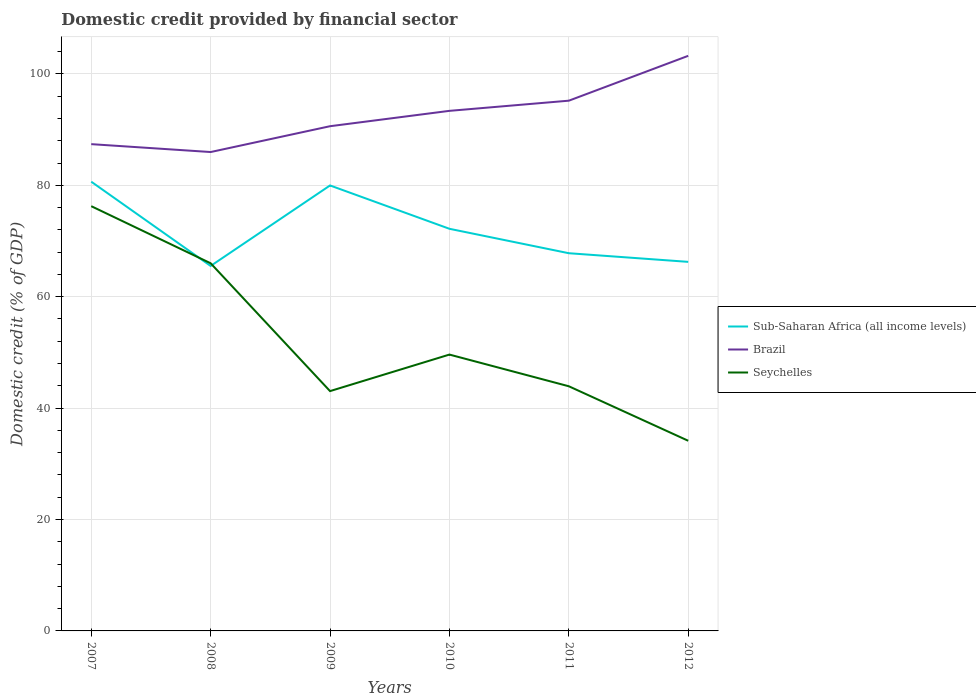How many different coloured lines are there?
Keep it short and to the point. 3. Does the line corresponding to Brazil intersect with the line corresponding to Sub-Saharan Africa (all income levels)?
Give a very brief answer. No. Is the number of lines equal to the number of legend labels?
Keep it short and to the point. Yes. Across all years, what is the maximum domestic credit in Sub-Saharan Africa (all income levels)?
Keep it short and to the point. 65.52. In which year was the domestic credit in Brazil maximum?
Your answer should be compact. 2008. What is the total domestic credit in Seychelles in the graph?
Keep it short and to the point. 5.69. What is the difference between the highest and the second highest domestic credit in Seychelles?
Make the answer very short. 42.11. Is the domestic credit in Brazil strictly greater than the domestic credit in Seychelles over the years?
Ensure brevity in your answer.  No. How many lines are there?
Ensure brevity in your answer.  3. How many years are there in the graph?
Your answer should be very brief. 6. Does the graph contain grids?
Your answer should be compact. Yes. Where does the legend appear in the graph?
Offer a terse response. Center right. How many legend labels are there?
Make the answer very short. 3. How are the legend labels stacked?
Provide a succinct answer. Vertical. What is the title of the graph?
Make the answer very short. Domestic credit provided by financial sector. What is the label or title of the Y-axis?
Provide a succinct answer. Domestic credit (% of GDP). What is the Domestic credit (% of GDP) of Sub-Saharan Africa (all income levels) in 2007?
Provide a short and direct response. 80.65. What is the Domestic credit (% of GDP) in Brazil in 2007?
Your response must be concise. 87.39. What is the Domestic credit (% of GDP) of Seychelles in 2007?
Keep it short and to the point. 76.25. What is the Domestic credit (% of GDP) of Sub-Saharan Africa (all income levels) in 2008?
Offer a very short reply. 65.52. What is the Domestic credit (% of GDP) of Brazil in 2008?
Provide a succinct answer. 85.97. What is the Domestic credit (% of GDP) of Seychelles in 2008?
Offer a very short reply. 66. What is the Domestic credit (% of GDP) of Sub-Saharan Africa (all income levels) in 2009?
Your answer should be very brief. 79.97. What is the Domestic credit (% of GDP) in Brazil in 2009?
Give a very brief answer. 90.61. What is the Domestic credit (% of GDP) of Seychelles in 2009?
Your answer should be compact. 43.05. What is the Domestic credit (% of GDP) of Sub-Saharan Africa (all income levels) in 2010?
Offer a very short reply. 72.19. What is the Domestic credit (% of GDP) of Brazil in 2010?
Provide a succinct answer. 93.36. What is the Domestic credit (% of GDP) in Seychelles in 2010?
Give a very brief answer. 49.61. What is the Domestic credit (% of GDP) in Sub-Saharan Africa (all income levels) in 2011?
Give a very brief answer. 67.81. What is the Domestic credit (% of GDP) in Brazil in 2011?
Make the answer very short. 95.19. What is the Domestic credit (% of GDP) in Seychelles in 2011?
Keep it short and to the point. 43.92. What is the Domestic credit (% of GDP) in Sub-Saharan Africa (all income levels) in 2012?
Provide a short and direct response. 66.26. What is the Domestic credit (% of GDP) of Brazil in 2012?
Make the answer very short. 103.24. What is the Domestic credit (% of GDP) in Seychelles in 2012?
Your answer should be very brief. 34.14. Across all years, what is the maximum Domestic credit (% of GDP) in Sub-Saharan Africa (all income levels)?
Offer a terse response. 80.65. Across all years, what is the maximum Domestic credit (% of GDP) in Brazil?
Your answer should be compact. 103.24. Across all years, what is the maximum Domestic credit (% of GDP) in Seychelles?
Your answer should be very brief. 76.25. Across all years, what is the minimum Domestic credit (% of GDP) in Sub-Saharan Africa (all income levels)?
Keep it short and to the point. 65.52. Across all years, what is the minimum Domestic credit (% of GDP) in Brazil?
Keep it short and to the point. 85.97. Across all years, what is the minimum Domestic credit (% of GDP) of Seychelles?
Make the answer very short. 34.14. What is the total Domestic credit (% of GDP) in Sub-Saharan Africa (all income levels) in the graph?
Ensure brevity in your answer.  432.39. What is the total Domestic credit (% of GDP) in Brazil in the graph?
Make the answer very short. 555.77. What is the total Domestic credit (% of GDP) in Seychelles in the graph?
Give a very brief answer. 312.98. What is the difference between the Domestic credit (% of GDP) of Sub-Saharan Africa (all income levels) in 2007 and that in 2008?
Your answer should be compact. 15.13. What is the difference between the Domestic credit (% of GDP) of Brazil in 2007 and that in 2008?
Your answer should be compact. 1.42. What is the difference between the Domestic credit (% of GDP) in Seychelles in 2007 and that in 2008?
Your response must be concise. 10.25. What is the difference between the Domestic credit (% of GDP) in Sub-Saharan Africa (all income levels) in 2007 and that in 2009?
Your answer should be very brief. 0.68. What is the difference between the Domestic credit (% of GDP) of Brazil in 2007 and that in 2009?
Your answer should be very brief. -3.22. What is the difference between the Domestic credit (% of GDP) of Seychelles in 2007 and that in 2009?
Your answer should be very brief. 33.2. What is the difference between the Domestic credit (% of GDP) in Sub-Saharan Africa (all income levels) in 2007 and that in 2010?
Offer a very short reply. 8.45. What is the difference between the Domestic credit (% of GDP) in Brazil in 2007 and that in 2010?
Your answer should be compact. -5.98. What is the difference between the Domestic credit (% of GDP) of Seychelles in 2007 and that in 2010?
Provide a succinct answer. 26.64. What is the difference between the Domestic credit (% of GDP) of Sub-Saharan Africa (all income levels) in 2007 and that in 2011?
Provide a succinct answer. 12.84. What is the difference between the Domestic credit (% of GDP) in Brazil in 2007 and that in 2011?
Ensure brevity in your answer.  -7.8. What is the difference between the Domestic credit (% of GDP) in Seychelles in 2007 and that in 2011?
Offer a very short reply. 32.33. What is the difference between the Domestic credit (% of GDP) in Sub-Saharan Africa (all income levels) in 2007 and that in 2012?
Your response must be concise. 14.39. What is the difference between the Domestic credit (% of GDP) of Brazil in 2007 and that in 2012?
Provide a succinct answer. -15.86. What is the difference between the Domestic credit (% of GDP) in Seychelles in 2007 and that in 2012?
Provide a succinct answer. 42.11. What is the difference between the Domestic credit (% of GDP) in Sub-Saharan Africa (all income levels) in 2008 and that in 2009?
Your answer should be compact. -14.45. What is the difference between the Domestic credit (% of GDP) of Brazil in 2008 and that in 2009?
Make the answer very short. -4.64. What is the difference between the Domestic credit (% of GDP) in Seychelles in 2008 and that in 2009?
Offer a very short reply. 22.95. What is the difference between the Domestic credit (% of GDP) in Sub-Saharan Africa (all income levels) in 2008 and that in 2010?
Your answer should be compact. -6.67. What is the difference between the Domestic credit (% of GDP) in Brazil in 2008 and that in 2010?
Ensure brevity in your answer.  -7.39. What is the difference between the Domestic credit (% of GDP) in Seychelles in 2008 and that in 2010?
Your answer should be compact. 16.39. What is the difference between the Domestic credit (% of GDP) in Sub-Saharan Africa (all income levels) in 2008 and that in 2011?
Keep it short and to the point. -2.29. What is the difference between the Domestic credit (% of GDP) in Brazil in 2008 and that in 2011?
Your response must be concise. -9.22. What is the difference between the Domestic credit (% of GDP) of Seychelles in 2008 and that in 2011?
Give a very brief answer. 22.08. What is the difference between the Domestic credit (% of GDP) in Sub-Saharan Africa (all income levels) in 2008 and that in 2012?
Your answer should be very brief. -0.73. What is the difference between the Domestic credit (% of GDP) in Brazil in 2008 and that in 2012?
Offer a terse response. -17.27. What is the difference between the Domestic credit (% of GDP) of Seychelles in 2008 and that in 2012?
Offer a terse response. 31.86. What is the difference between the Domestic credit (% of GDP) in Sub-Saharan Africa (all income levels) in 2009 and that in 2010?
Your response must be concise. 7.78. What is the difference between the Domestic credit (% of GDP) of Brazil in 2009 and that in 2010?
Ensure brevity in your answer.  -2.76. What is the difference between the Domestic credit (% of GDP) of Seychelles in 2009 and that in 2010?
Provide a short and direct response. -6.56. What is the difference between the Domestic credit (% of GDP) of Sub-Saharan Africa (all income levels) in 2009 and that in 2011?
Give a very brief answer. 12.16. What is the difference between the Domestic credit (% of GDP) of Brazil in 2009 and that in 2011?
Make the answer very short. -4.58. What is the difference between the Domestic credit (% of GDP) of Seychelles in 2009 and that in 2011?
Provide a short and direct response. -0.87. What is the difference between the Domestic credit (% of GDP) of Sub-Saharan Africa (all income levels) in 2009 and that in 2012?
Your answer should be very brief. 13.72. What is the difference between the Domestic credit (% of GDP) in Brazil in 2009 and that in 2012?
Your response must be concise. -12.64. What is the difference between the Domestic credit (% of GDP) in Seychelles in 2009 and that in 2012?
Ensure brevity in your answer.  8.92. What is the difference between the Domestic credit (% of GDP) of Sub-Saharan Africa (all income levels) in 2010 and that in 2011?
Ensure brevity in your answer.  4.39. What is the difference between the Domestic credit (% of GDP) of Brazil in 2010 and that in 2011?
Keep it short and to the point. -1.83. What is the difference between the Domestic credit (% of GDP) in Seychelles in 2010 and that in 2011?
Keep it short and to the point. 5.69. What is the difference between the Domestic credit (% of GDP) in Sub-Saharan Africa (all income levels) in 2010 and that in 2012?
Make the answer very short. 5.94. What is the difference between the Domestic credit (% of GDP) in Brazil in 2010 and that in 2012?
Give a very brief answer. -9.88. What is the difference between the Domestic credit (% of GDP) in Seychelles in 2010 and that in 2012?
Make the answer very short. 15.47. What is the difference between the Domestic credit (% of GDP) of Sub-Saharan Africa (all income levels) in 2011 and that in 2012?
Your answer should be compact. 1.55. What is the difference between the Domestic credit (% of GDP) in Brazil in 2011 and that in 2012?
Offer a terse response. -8.05. What is the difference between the Domestic credit (% of GDP) in Seychelles in 2011 and that in 2012?
Ensure brevity in your answer.  9.78. What is the difference between the Domestic credit (% of GDP) in Sub-Saharan Africa (all income levels) in 2007 and the Domestic credit (% of GDP) in Brazil in 2008?
Keep it short and to the point. -5.32. What is the difference between the Domestic credit (% of GDP) of Sub-Saharan Africa (all income levels) in 2007 and the Domestic credit (% of GDP) of Seychelles in 2008?
Your answer should be compact. 14.65. What is the difference between the Domestic credit (% of GDP) in Brazil in 2007 and the Domestic credit (% of GDP) in Seychelles in 2008?
Keep it short and to the point. 21.38. What is the difference between the Domestic credit (% of GDP) in Sub-Saharan Africa (all income levels) in 2007 and the Domestic credit (% of GDP) in Brazil in 2009?
Ensure brevity in your answer.  -9.96. What is the difference between the Domestic credit (% of GDP) of Sub-Saharan Africa (all income levels) in 2007 and the Domestic credit (% of GDP) of Seychelles in 2009?
Offer a very short reply. 37.59. What is the difference between the Domestic credit (% of GDP) in Brazil in 2007 and the Domestic credit (% of GDP) in Seychelles in 2009?
Keep it short and to the point. 44.33. What is the difference between the Domestic credit (% of GDP) in Sub-Saharan Africa (all income levels) in 2007 and the Domestic credit (% of GDP) in Brazil in 2010?
Provide a short and direct response. -12.72. What is the difference between the Domestic credit (% of GDP) in Sub-Saharan Africa (all income levels) in 2007 and the Domestic credit (% of GDP) in Seychelles in 2010?
Your answer should be compact. 31.04. What is the difference between the Domestic credit (% of GDP) in Brazil in 2007 and the Domestic credit (% of GDP) in Seychelles in 2010?
Offer a very short reply. 37.78. What is the difference between the Domestic credit (% of GDP) in Sub-Saharan Africa (all income levels) in 2007 and the Domestic credit (% of GDP) in Brazil in 2011?
Offer a very short reply. -14.54. What is the difference between the Domestic credit (% of GDP) of Sub-Saharan Africa (all income levels) in 2007 and the Domestic credit (% of GDP) of Seychelles in 2011?
Keep it short and to the point. 36.73. What is the difference between the Domestic credit (% of GDP) in Brazil in 2007 and the Domestic credit (% of GDP) in Seychelles in 2011?
Keep it short and to the point. 43.47. What is the difference between the Domestic credit (% of GDP) in Sub-Saharan Africa (all income levels) in 2007 and the Domestic credit (% of GDP) in Brazil in 2012?
Provide a succinct answer. -22.6. What is the difference between the Domestic credit (% of GDP) of Sub-Saharan Africa (all income levels) in 2007 and the Domestic credit (% of GDP) of Seychelles in 2012?
Make the answer very short. 46.51. What is the difference between the Domestic credit (% of GDP) of Brazil in 2007 and the Domestic credit (% of GDP) of Seychelles in 2012?
Provide a succinct answer. 53.25. What is the difference between the Domestic credit (% of GDP) in Sub-Saharan Africa (all income levels) in 2008 and the Domestic credit (% of GDP) in Brazil in 2009?
Provide a succinct answer. -25.09. What is the difference between the Domestic credit (% of GDP) in Sub-Saharan Africa (all income levels) in 2008 and the Domestic credit (% of GDP) in Seychelles in 2009?
Make the answer very short. 22.47. What is the difference between the Domestic credit (% of GDP) of Brazil in 2008 and the Domestic credit (% of GDP) of Seychelles in 2009?
Keep it short and to the point. 42.92. What is the difference between the Domestic credit (% of GDP) in Sub-Saharan Africa (all income levels) in 2008 and the Domestic credit (% of GDP) in Brazil in 2010?
Provide a succinct answer. -27.84. What is the difference between the Domestic credit (% of GDP) of Sub-Saharan Africa (all income levels) in 2008 and the Domestic credit (% of GDP) of Seychelles in 2010?
Give a very brief answer. 15.91. What is the difference between the Domestic credit (% of GDP) of Brazil in 2008 and the Domestic credit (% of GDP) of Seychelles in 2010?
Ensure brevity in your answer.  36.36. What is the difference between the Domestic credit (% of GDP) in Sub-Saharan Africa (all income levels) in 2008 and the Domestic credit (% of GDP) in Brazil in 2011?
Your response must be concise. -29.67. What is the difference between the Domestic credit (% of GDP) in Sub-Saharan Africa (all income levels) in 2008 and the Domestic credit (% of GDP) in Seychelles in 2011?
Your response must be concise. 21.6. What is the difference between the Domestic credit (% of GDP) in Brazil in 2008 and the Domestic credit (% of GDP) in Seychelles in 2011?
Your answer should be compact. 42.05. What is the difference between the Domestic credit (% of GDP) of Sub-Saharan Africa (all income levels) in 2008 and the Domestic credit (% of GDP) of Brazil in 2012?
Keep it short and to the point. -37.72. What is the difference between the Domestic credit (% of GDP) in Sub-Saharan Africa (all income levels) in 2008 and the Domestic credit (% of GDP) in Seychelles in 2012?
Provide a succinct answer. 31.38. What is the difference between the Domestic credit (% of GDP) of Brazil in 2008 and the Domestic credit (% of GDP) of Seychelles in 2012?
Provide a short and direct response. 51.83. What is the difference between the Domestic credit (% of GDP) in Sub-Saharan Africa (all income levels) in 2009 and the Domestic credit (% of GDP) in Brazil in 2010?
Keep it short and to the point. -13.39. What is the difference between the Domestic credit (% of GDP) of Sub-Saharan Africa (all income levels) in 2009 and the Domestic credit (% of GDP) of Seychelles in 2010?
Offer a very short reply. 30.36. What is the difference between the Domestic credit (% of GDP) in Brazil in 2009 and the Domestic credit (% of GDP) in Seychelles in 2010?
Provide a succinct answer. 41. What is the difference between the Domestic credit (% of GDP) of Sub-Saharan Africa (all income levels) in 2009 and the Domestic credit (% of GDP) of Brazil in 2011?
Offer a very short reply. -15.22. What is the difference between the Domestic credit (% of GDP) in Sub-Saharan Africa (all income levels) in 2009 and the Domestic credit (% of GDP) in Seychelles in 2011?
Offer a very short reply. 36.05. What is the difference between the Domestic credit (% of GDP) of Brazil in 2009 and the Domestic credit (% of GDP) of Seychelles in 2011?
Your response must be concise. 46.69. What is the difference between the Domestic credit (% of GDP) in Sub-Saharan Africa (all income levels) in 2009 and the Domestic credit (% of GDP) in Brazil in 2012?
Ensure brevity in your answer.  -23.27. What is the difference between the Domestic credit (% of GDP) of Sub-Saharan Africa (all income levels) in 2009 and the Domestic credit (% of GDP) of Seychelles in 2012?
Your answer should be very brief. 45.83. What is the difference between the Domestic credit (% of GDP) in Brazil in 2009 and the Domestic credit (% of GDP) in Seychelles in 2012?
Your response must be concise. 56.47. What is the difference between the Domestic credit (% of GDP) of Sub-Saharan Africa (all income levels) in 2010 and the Domestic credit (% of GDP) of Brazil in 2011?
Your answer should be compact. -23. What is the difference between the Domestic credit (% of GDP) in Sub-Saharan Africa (all income levels) in 2010 and the Domestic credit (% of GDP) in Seychelles in 2011?
Ensure brevity in your answer.  28.27. What is the difference between the Domestic credit (% of GDP) of Brazil in 2010 and the Domestic credit (% of GDP) of Seychelles in 2011?
Your answer should be very brief. 49.44. What is the difference between the Domestic credit (% of GDP) of Sub-Saharan Africa (all income levels) in 2010 and the Domestic credit (% of GDP) of Brazil in 2012?
Make the answer very short. -31.05. What is the difference between the Domestic credit (% of GDP) of Sub-Saharan Africa (all income levels) in 2010 and the Domestic credit (% of GDP) of Seychelles in 2012?
Your answer should be compact. 38.05. What is the difference between the Domestic credit (% of GDP) of Brazil in 2010 and the Domestic credit (% of GDP) of Seychelles in 2012?
Provide a short and direct response. 59.23. What is the difference between the Domestic credit (% of GDP) in Sub-Saharan Africa (all income levels) in 2011 and the Domestic credit (% of GDP) in Brazil in 2012?
Your response must be concise. -35.44. What is the difference between the Domestic credit (% of GDP) in Sub-Saharan Africa (all income levels) in 2011 and the Domestic credit (% of GDP) in Seychelles in 2012?
Make the answer very short. 33.67. What is the difference between the Domestic credit (% of GDP) of Brazil in 2011 and the Domestic credit (% of GDP) of Seychelles in 2012?
Keep it short and to the point. 61.05. What is the average Domestic credit (% of GDP) in Sub-Saharan Africa (all income levels) per year?
Provide a succinct answer. 72.07. What is the average Domestic credit (% of GDP) of Brazil per year?
Provide a succinct answer. 92.63. What is the average Domestic credit (% of GDP) of Seychelles per year?
Provide a short and direct response. 52.16. In the year 2007, what is the difference between the Domestic credit (% of GDP) of Sub-Saharan Africa (all income levels) and Domestic credit (% of GDP) of Brazil?
Your response must be concise. -6.74. In the year 2007, what is the difference between the Domestic credit (% of GDP) in Sub-Saharan Africa (all income levels) and Domestic credit (% of GDP) in Seychelles?
Provide a succinct answer. 4.4. In the year 2007, what is the difference between the Domestic credit (% of GDP) of Brazil and Domestic credit (% of GDP) of Seychelles?
Give a very brief answer. 11.13. In the year 2008, what is the difference between the Domestic credit (% of GDP) of Sub-Saharan Africa (all income levels) and Domestic credit (% of GDP) of Brazil?
Your answer should be very brief. -20.45. In the year 2008, what is the difference between the Domestic credit (% of GDP) of Sub-Saharan Africa (all income levels) and Domestic credit (% of GDP) of Seychelles?
Your answer should be compact. -0.48. In the year 2008, what is the difference between the Domestic credit (% of GDP) in Brazil and Domestic credit (% of GDP) in Seychelles?
Offer a terse response. 19.97. In the year 2009, what is the difference between the Domestic credit (% of GDP) in Sub-Saharan Africa (all income levels) and Domestic credit (% of GDP) in Brazil?
Give a very brief answer. -10.64. In the year 2009, what is the difference between the Domestic credit (% of GDP) in Sub-Saharan Africa (all income levels) and Domestic credit (% of GDP) in Seychelles?
Provide a short and direct response. 36.92. In the year 2009, what is the difference between the Domestic credit (% of GDP) of Brazil and Domestic credit (% of GDP) of Seychelles?
Your response must be concise. 47.55. In the year 2010, what is the difference between the Domestic credit (% of GDP) of Sub-Saharan Africa (all income levels) and Domestic credit (% of GDP) of Brazil?
Offer a very short reply. -21.17. In the year 2010, what is the difference between the Domestic credit (% of GDP) of Sub-Saharan Africa (all income levels) and Domestic credit (% of GDP) of Seychelles?
Your response must be concise. 22.58. In the year 2010, what is the difference between the Domestic credit (% of GDP) of Brazil and Domestic credit (% of GDP) of Seychelles?
Your response must be concise. 43.75. In the year 2011, what is the difference between the Domestic credit (% of GDP) of Sub-Saharan Africa (all income levels) and Domestic credit (% of GDP) of Brazil?
Your answer should be compact. -27.38. In the year 2011, what is the difference between the Domestic credit (% of GDP) of Sub-Saharan Africa (all income levels) and Domestic credit (% of GDP) of Seychelles?
Your answer should be compact. 23.89. In the year 2011, what is the difference between the Domestic credit (% of GDP) in Brazil and Domestic credit (% of GDP) in Seychelles?
Keep it short and to the point. 51.27. In the year 2012, what is the difference between the Domestic credit (% of GDP) in Sub-Saharan Africa (all income levels) and Domestic credit (% of GDP) in Brazil?
Your answer should be very brief. -36.99. In the year 2012, what is the difference between the Domestic credit (% of GDP) of Sub-Saharan Africa (all income levels) and Domestic credit (% of GDP) of Seychelles?
Provide a succinct answer. 32.12. In the year 2012, what is the difference between the Domestic credit (% of GDP) of Brazil and Domestic credit (% of GDP) of Seychelles?
Offer a terse response. 69.11. What is the ratio of the Domestic credit (% of GDP) in Sub-Saharan Africa (all income levels) in 2007 to that in 2008?
Your response must be concise. 1.23. What is the ratio of the Domestic credit (% of GDP) of Brazil in 2007 to that in 2008?
Your answer should be very brief. 1.02. What is the ratio of the Domestic credit (% of GDP) in Seychelles in 2007 to that in 2008?
Your answer should be very brief. 1.16. What is the ratio of the Domestic credit (% of GDP) of Sub-Saharan Africa (all income levels) in 2007 to that in 2009?
Ensure brevity in your answer.  1.01. What is the ratio of the Domestic credit (% of GDP) of Brazil in 2007 to that in 2009?
Provide a succinct answer. 0.96. What is the ratio of the Domestic credit (% of GDP) of Seychelles in 2007 to that in 2009?
Give a very brief answer. 1.77. What is the ratio of the Domestic credit (% of GDP) in Sub-Saharan Africa (all income levels) in 2007 to that in 2010?
Your response must be concise. 1.12. What is the ratio of the Domestic credit (% of GDP) of Brazil in 2007 to that in 2010?
Your response must be concise. 0.94. What is the ratio of the Domestic credit (% of GDP) in Seychelles in 2007 to that in 2010?
Offer a terse response. 1.54. What is the ratio of the Domestic credit (% of GDP) in Sub-Saharan Africa (all income levels) in 2007 to that in 2011?
Your answer should be very brief. 1.19. What is the ratio of the Domestic credit (% of GDP) of Brazil in 2007 to that in 2011?
Make the answer very short. 0.92. What is the ratio of the Domestic credit (% of GDP) in Seychelles in 2007 to that in 2011?
Provide a succinct answer. 1.74. What is the ratio of the Domestic credit (% of GDP) in Sub-Saharan Africa (all income levels) in 2007 to that in 2012?
Offer a terse response. 1.22. What is the ratio of the Domestic credit (% of GDP) in Brazil in 2007 to that in 2012?
Give a very brief answer. 0.85. What is the ratio of the Domestic credit (% of GDP) in Seychelles in 2007 to that in 2012?
Your answer should be compact. 2.23. What is the ratio of the Domestic credit (% of GDP) in Sub-Saharan Africa (all income levels) in 2008 to that in 2009?
Your response must be concise. 0.82. What is the ratio of the Domestic credit (% of GDP) in Brazil in 2008 to that in 2009?
Offer a terse response. 0.95. What is the ratio of the Domestic credit (% of GDP) of Seychelles in 2008 to that in 2009?
Your response must be concise. 1.53. What is the ratio of the Domestic credit (% of GDP) of Sub-Saharan Africa (all income levels) in 2008 to that in 2010?
Your response must be concise. 0.91. What is the ratio of the Domestic credit (% of GDP) of Brazil in 2008 to that in 2010?
Provide a short and direct response. 0.92. What is the ratio of the Domestic credit (% of GDP) of Seychelles in 2008 to that in 2010?
Keep it short and to the point. 1.33. What is the ratio of the Domestic credit (% of GDP) of Sub-Saharan Africa (all income levels) in 2008 to that in 2011?
Provide a succinct answer. 0.97. What is the ratio of the Domestic credit (% of GDP) of Brazil in 2008 to that in 2011?
Ensure brevity in your answer.  0.9. What is the ratio of the Domestic credit (% of GDP) of Seychelles in 2008 to that in 2011?
Give a very brief answer. 1.5. What is the ratio of the Domestic credit (% of GDP) of Sub-Saharan Africa (all income levels) in 2008 to that in 2012?
Offer a terse response. 0.99. What is the ratio of the Domestic credit (% of GDP) of Brazil in 2008 to that in 2012?
Your answer should be very brief. 0.83. What is the ratio of the Domestic credit (% of GDP) of Seychelles in 2008 to that in 2012?
Provide a short and direct response. 1.93. What is the ratio of the Domestic credit (% of GDP) of Sub-Saharan Africa (all income levels) in 2009 to that in 2010?
Your answer should be very brief. 1.11. What is the ratio of the Domestic credit (% of GDP) of Brazil in 2009 to that in 2010?
Offer a very short reply. 0.97. What is the ratio of the Domestic credit (% of GDP) of Seychelles in 2009 to that in 2010?
Provide a short and direct response. 0.87. What is the ratio of the Domestic credit (% of GDP) in Sub-Saharan Africa (all income levels) in 2009 to that in 2011?
Your answer should be compact. 1.18. What is the ratio of the Domestic credit (% of GDP) of Brazil in 2009 to that in 2011?
Keep it short and to the point. 0.95. What is the ratio of the Domestic credit (% of GDP) of Seychelles in 2009 to that in 2011?
Your answer should be very brief. 0.98. What is the ratio of the Domestic credit (% of GDP) of Sub-Saharan Africa (all income levels) in 2009 to that in 2012?
Your answer should be very brief. 1.21. What is the ratio of the Domestic credit (% of GDP) in Brazil in 2009 to that in 2012?
Provide a succinct answer. 0.88. What is the ratio of the Domestic credit (% of GDP) in Seychelles in 2009 to that in 2012?
Your answer should be very brief. 1.26. What is the ratio of the Domestic credit (% of GDP) of Sub-Saharan Africa (all income levels) in 2010 to that in 2011?
Provide a succinct answer. 1.06. What is the ratio of the Domestic credit (% of GDP) in Brazil in 2010 to that in 2011?
Your response must be concise. 0.98. What is the ratio of the Domestic credit (% of GDP) of Seychelles in 2010 to that in 2011?
Your answer should be very brief. 1.13. What is the ratio of the Domestic credit (% of GDP) in Sub-Saharan Africa (all income levels) in 2010 to that in 2012?
Ensure brevity in your answer.  1.09. What is the ratio of the Domestic credit (% of GDP) of Brazil in 2010 to that in 2012?
Your response must be concise. 0.9. What is the ratio of the Domestic credit (% of GDP) in Seychelles in 2010 to that in 2012?
Your answer should be compact. 1.45. What is the ratio of the Domestic credit (% of GDP) of Sub-Saharan Africa (all income levels) in 2011 to that in 2012?
Provide a short and direct response. 1.02. What is the ratio of the Domestic credit (% of GDP) in Brazil in 2011 to that in 2012?
Keep it short and to the point. 0.92. What is the ratio of the Domestic credit (% of GDP) of Seychelles in 2011 to that in 2012?
Ensure brevity in your answer.  1.29. What is the difference between the highest and the second highest Domestic credit (% of GDP) in Sub-Saharan Africa (all income levels)?
Provide a succinct answer. 0.68. What is the difference between the highest and the second highest Domestic credit (% of GDP) of Brazil?
Offer a terse response. 8.05. What is the difference between the highest and the second highest Domestic credit (% of GDP) in Seychelles?
Give a very brief answer. 10.25. What is the difference between the highest and the lowest Domestic credit (% of GDP) in Sub-Saharan Africa (all income levels)?
Your answer should be compact. 15.13. What is the difference between the highest and the lowest Domestic credit (% of GDP) of Brazil?
Provide a succinct answer. 17.27. What is the difference between the highest and the lowest Domestic credit (% of GDP) of Seychelles?
Keep it short and to the point. 42.11. 